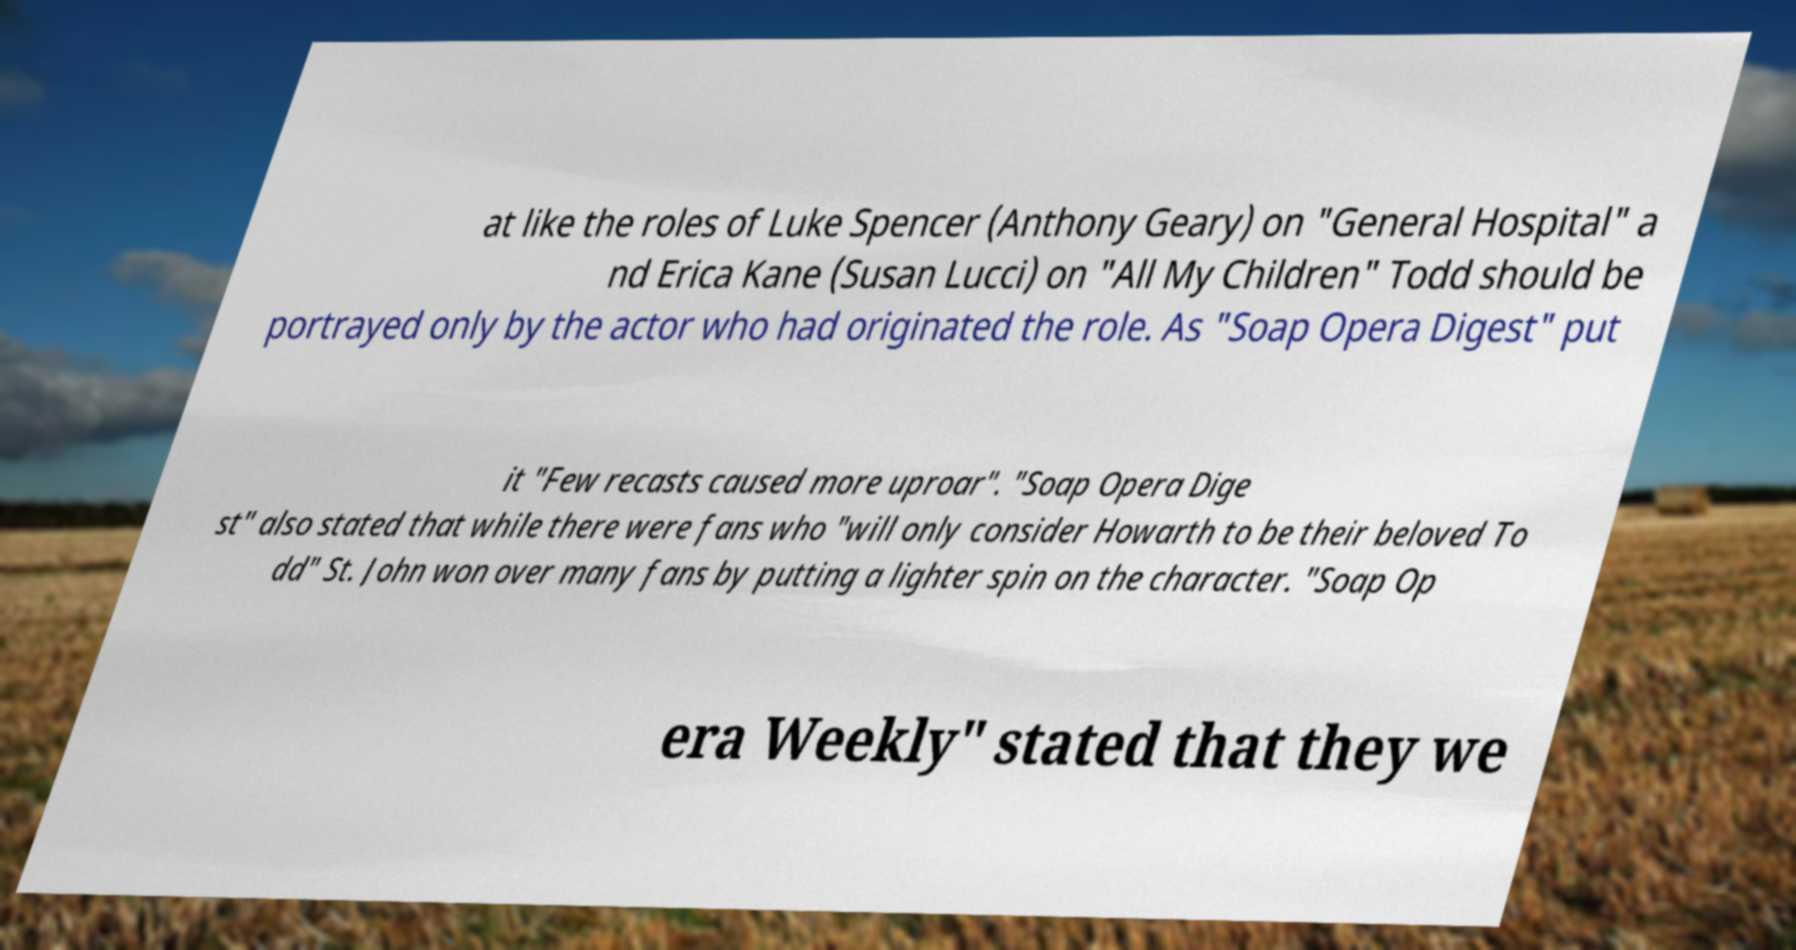Can you read and provide the text displayed in the image?This photo seems to have some interesting text. Can you extract and type it out for me? at like the roles of Luke Spencer (Anthony Geary) on "General Hospital" a nd Erica Kane (Susan Lucci) on "All My Children" Todd should be portrayed only by the actor who had originated the role. As "Soap Opera Digest" put it "Few recasts caused more uproar". "Soap Opera Dige st" also stated that while there were fans who "will only consider Howarth to be their beloved To dd" St. John won over many fans by putting a lighter spin on the character. "Soap Op era Weekly" stated that they we 